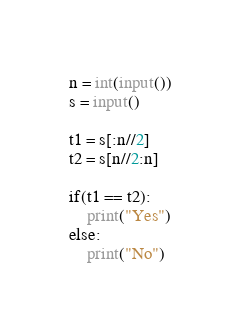<code> <loc_0><loc_0><loc_500><loc_500><_Python_>n = int(input())
s = input()

t1 = s[:n//2]
t2 = s[n//2:n]

if(t1 == t2):
    print("Yes")
else:
    print("No")

</code> 